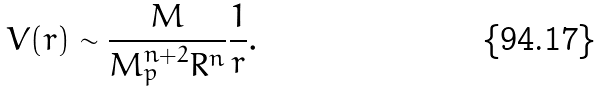<formula> <loc_0><loc_0><loc_500><loc_500>V ( r ) \sim \frac { M } { M _ { p } ^ { n + 2 } R ^ { n } } \frac { 1 } { r } .</formula> 